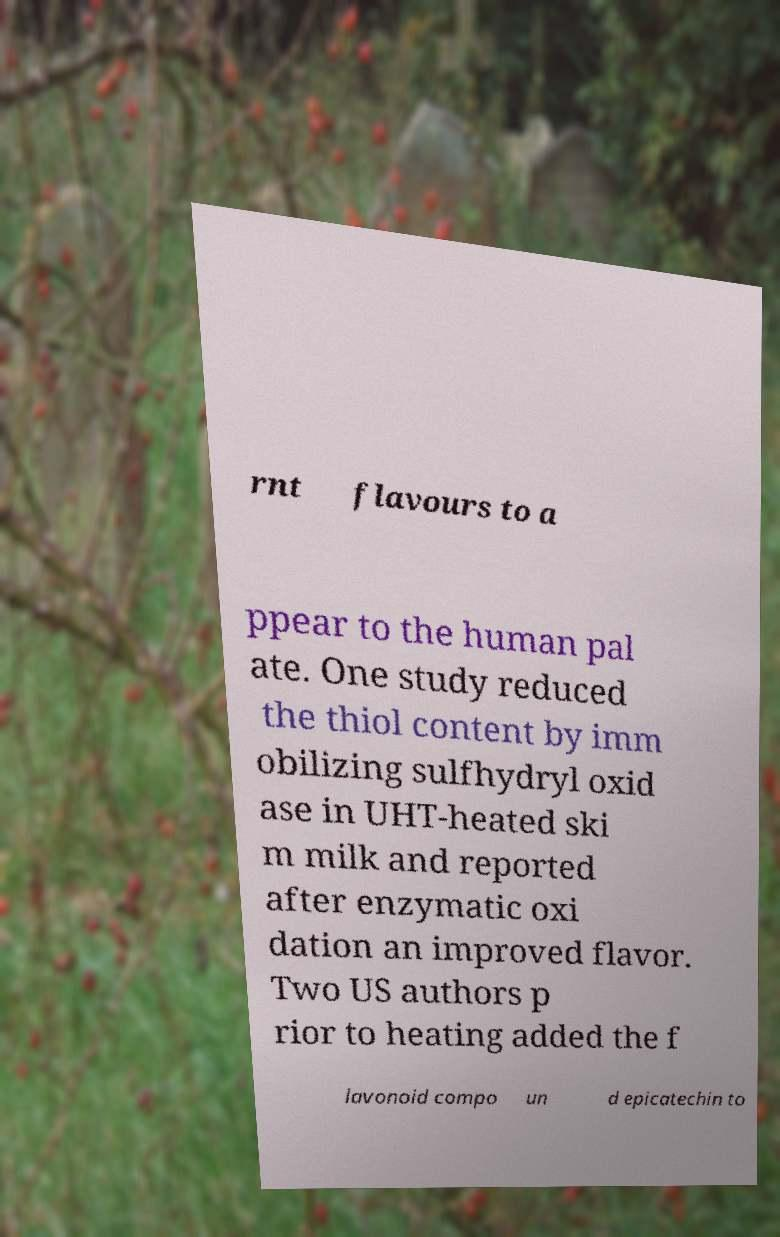Please read and relay the text visible in this image. What does it say? rnt flavours to a ppear to the human pal ate. One study reduced the thiol content by imm obilizing sulfhydryl oxid ase in UHT-heated ski m milk and reported after enzymatic oxi dation an improved flavor. Two US authors p rior to heating added the f lavonoid compo un d epicatechin to 